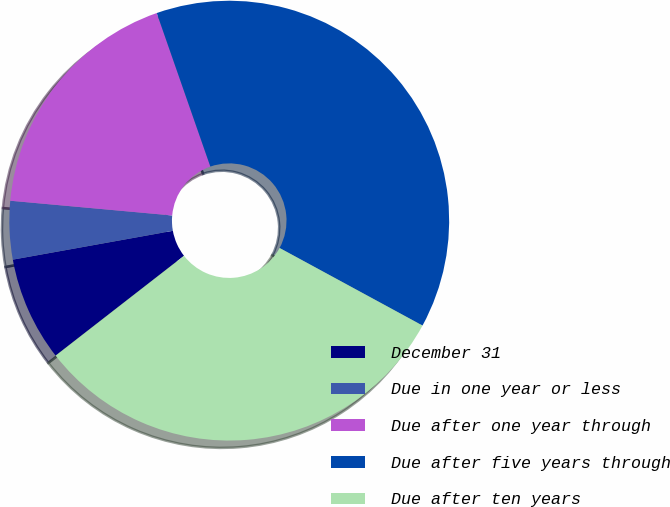Convert chart. <chart><loc_0><loc_0><loc_500><loc_500><pie_chart><fcel>December 31<fcel>Due in one year or less<fcel>Due after one year through<fcel>Due after five years through<fcel>Due after ten years<nl><fcel>7.68%<fcel>4.28%<fcel>18.21%<fcel>38.26%<fcel>31.57%<nl></chart> 